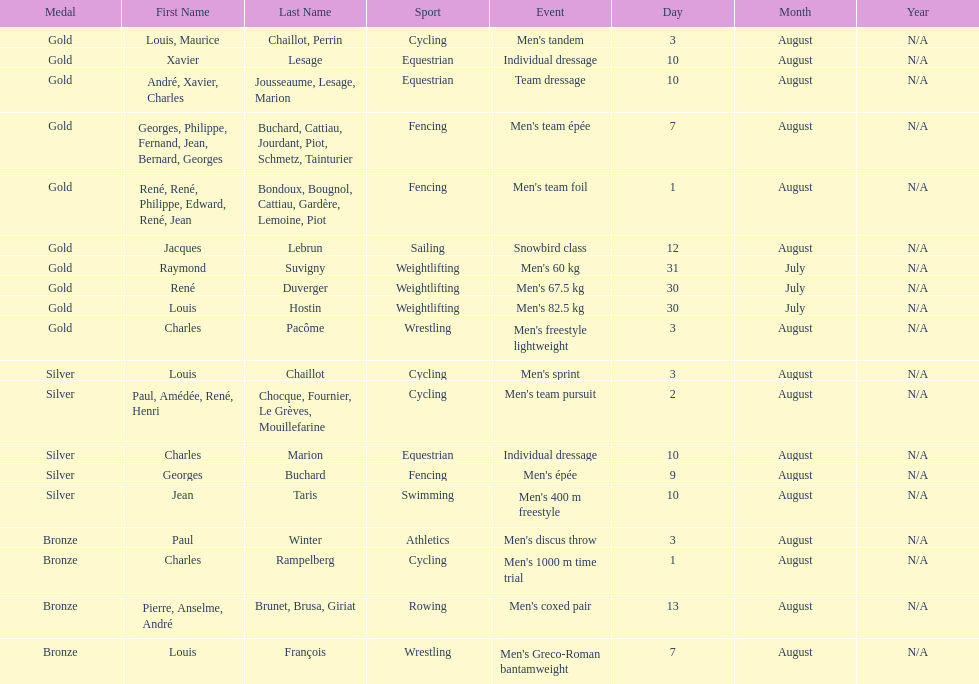Louis chaillot won a gold medal for cycling and a silver medal for what sport? Cycling. 